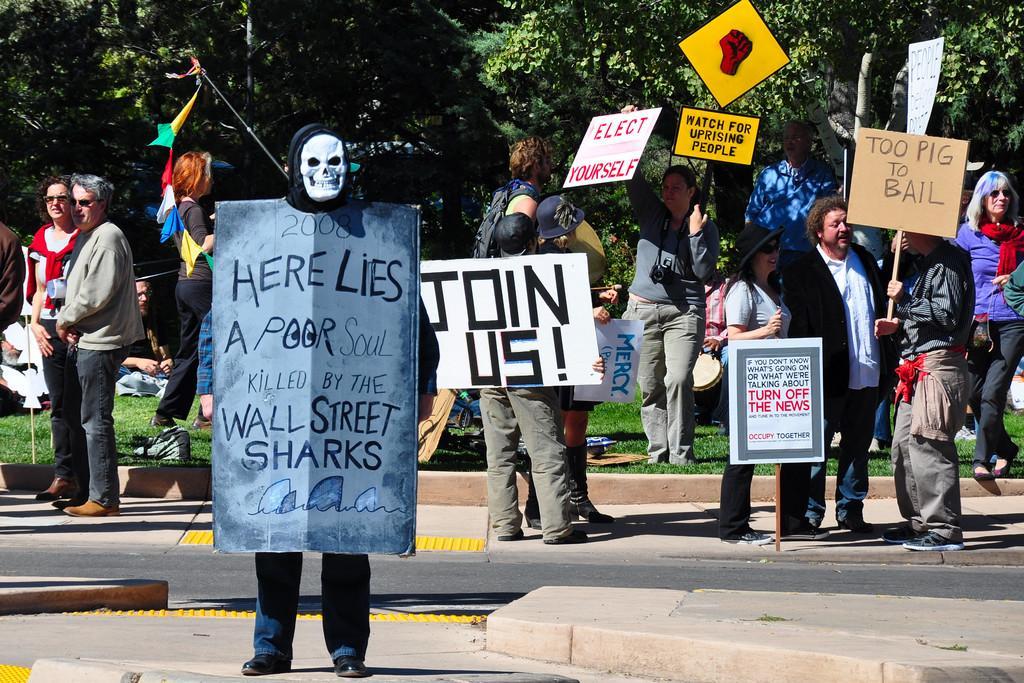Please provide a concise description of this image. In the foreground I can see a crowd, wearing a mask and holding boards in their hand are standing on the road. In the background I can see trees. This image is taken during a sunny day. 